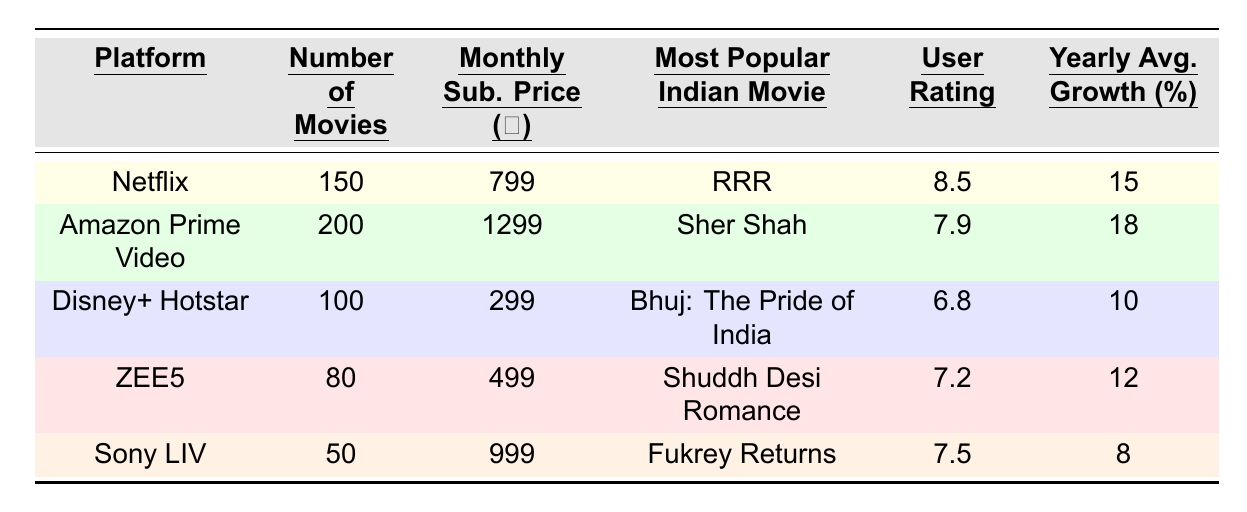What is the most popular Indian movie on Netflix? From the table, the entry for Netflix shows that its most popular Indian movie is "RRR".
Answer: RRR How many movies are available on Amazon Prime Video? The table indicates that Amazon Prime Video has 200 movies listed under its platform.
Answer: 200 Which platform has the highest user rating for Indian movies? By comparing the user ratings across platforms, Netflix has the highest user rating at 8.5.
Answer: Netflix What is the monthly subscription price for Disney+ Hotstar? The table lists the monthly subscription price for Disney+ Hotstar as ₹299.
Answer: ₹299 What is the difference in the number of movies between Amazon Prime Video and ZEE5? To determine the difference, subtract the number of movies on ZEE5 (80) from Amazon Prime Video (200), resulting in 200 - 80 = 120.
Answer: 120 Is the user rating for Sony LIV greater than 7? Upon checking the table, the user rating for Sony LIV is 7.5, which is greater than 7.
Answer: Yes What is the average monthly subscription price across all platforms? The average can be calculated by summing the prices (799 + 1299 + 299 + 499 + 999 = 2895) and dividing by the number of platforms (5), which gives 2895/5 = 579.
Answer: ₹579 Which platform has the lowest number of movies? Comparing the number of movies listed, Sony LIV has the lowest at 50 movies.
Answer: Sony LIV Calculate the yearly average growth for Netflix and Amazon Prime Video combined. To find the combined yearly average growth, add their percentages (15 + 18 = 33) and divide by 2. Hence, the average is 33/2 = 16.5.
Answer: 16.5% Which platform has both the lowest user rating and lowest number of movies? By examining the table, Disney+ Hotstar has the lowest user rating (6.8) and also has fewer movies than ZEE5; therefore, it meets both criteria.
Answer: Disney+ Hotstar 